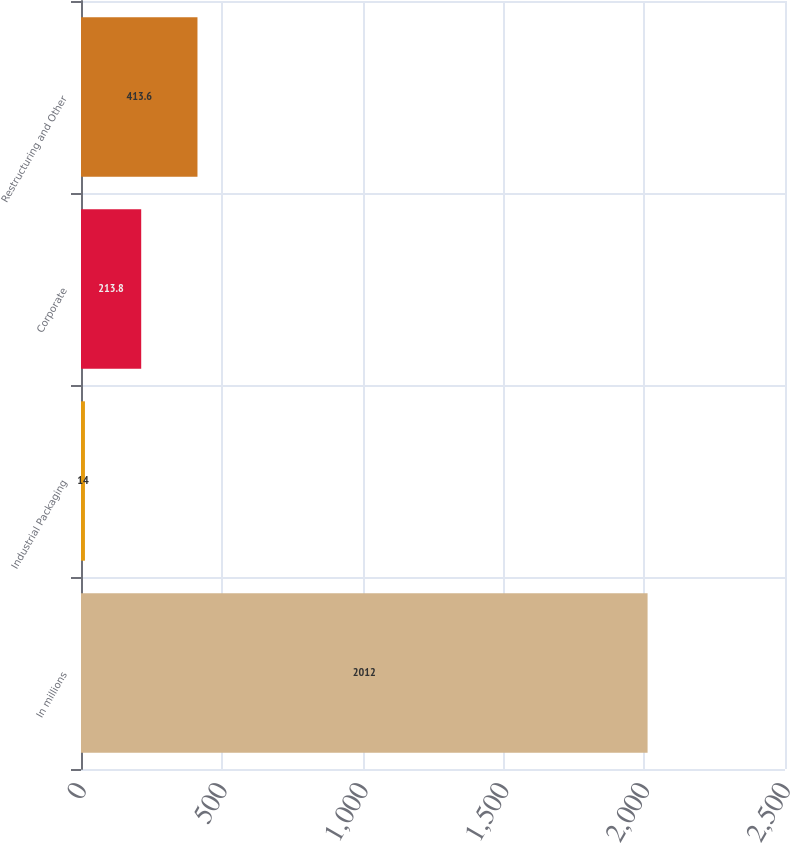Convert chart to OTSL. <chart><loc_0><loc_0><loc_500><loc_500><bar_chart><fcel>In millions<fcel>Industrial Packaging<fcel>Corporate<fcel>Restructuring and Other<nl><fcel>2012<fcel>14<fcel>213.8<fcel>413.6<nl></chart> 